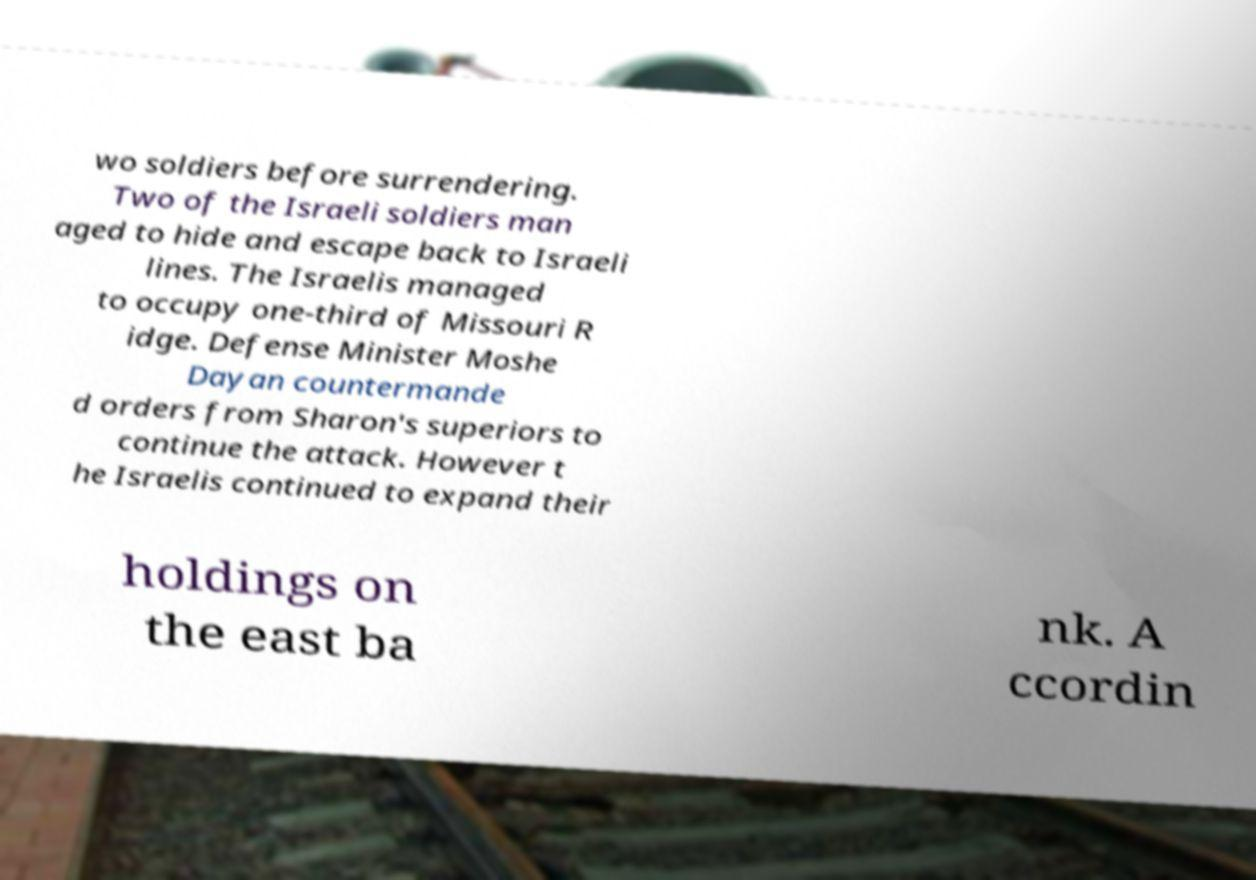Can you read and provide the text displayed in the image?This photo seems to have some interesting text. Can you extract and type it out for me? wo soldiers before surrendering. Two of the Israeli soldiers man aged to hide and escape back to Israeli lines. The Israelis managed to occupy one-third of Missouri R idge. Defense Minister Moshe Dayan countermande d orders from Sharon's superiors to continue the attack. However t he Israelis continued to expand their holdings on the east ba nk. A ccordin 